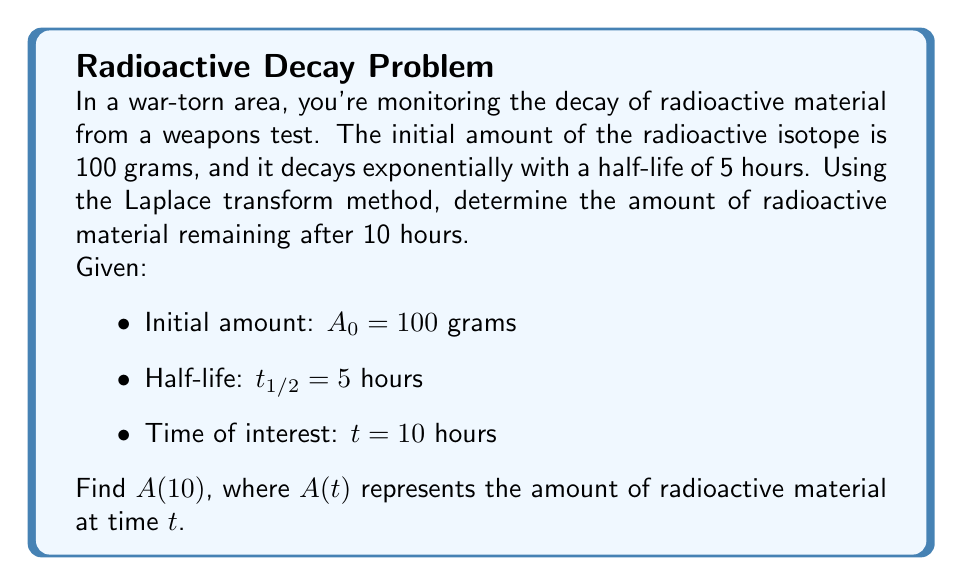Provide a solution to this math problem. Let's approach this problem step-by-step using the Laplace transform method:

1) The decay of radioactive material follows the exponential decay formula:
   $$A(t) = A_0e^{-\lambda t}$$
   where $\lambda$ is the decay constant.

2) We need to find $\lambda$ using the half-life:
   $$t_{1/2} = \frac{\ln(2)}{\lambda}$$
   $$\lambda = \frac{\ln(2)}{t_{1/2}} = \frac{\ln(2)}{5} \approx 0.1386$$

3) Now our equation is:
   $$A(t) = 100e^{-0.1386t}$$

4) To solve this using Laplace transforms, let's take the Laplace transform of both sides:
   $$\mathcal{L}\{A(t)\} = \mathcal{L}\{100e^{-0.1386t}\}$$

5) Using the property of Laplace transforms for exponential functions:
   $$A(s) = \frac{100}{s + 0.1386}$$

6) To find $A(10)$, we need to take the inverse Laplace transform and evaluate at $t=10$:
   $$A(t) = 100e^{-0.1386t}$$

7) Evaluating at $t=10$:
   $$A(10) = 100e^{-0.1386(10)} \approx 25.0256$$

Therefore, after 10 hours, approximately 25.0256 grams of the radioactive material remain.
Answer: $A(10) \approx 25.0256$ grams 